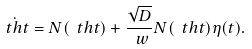<formula> <loc_0><loc_0><loc_500><loc_500>\dot { \ t h t } = N ( \ t h t ) + \frac { \sqrt { D } } { \ w } N ( \ t h t ) \eta ( t ) .</formula> 